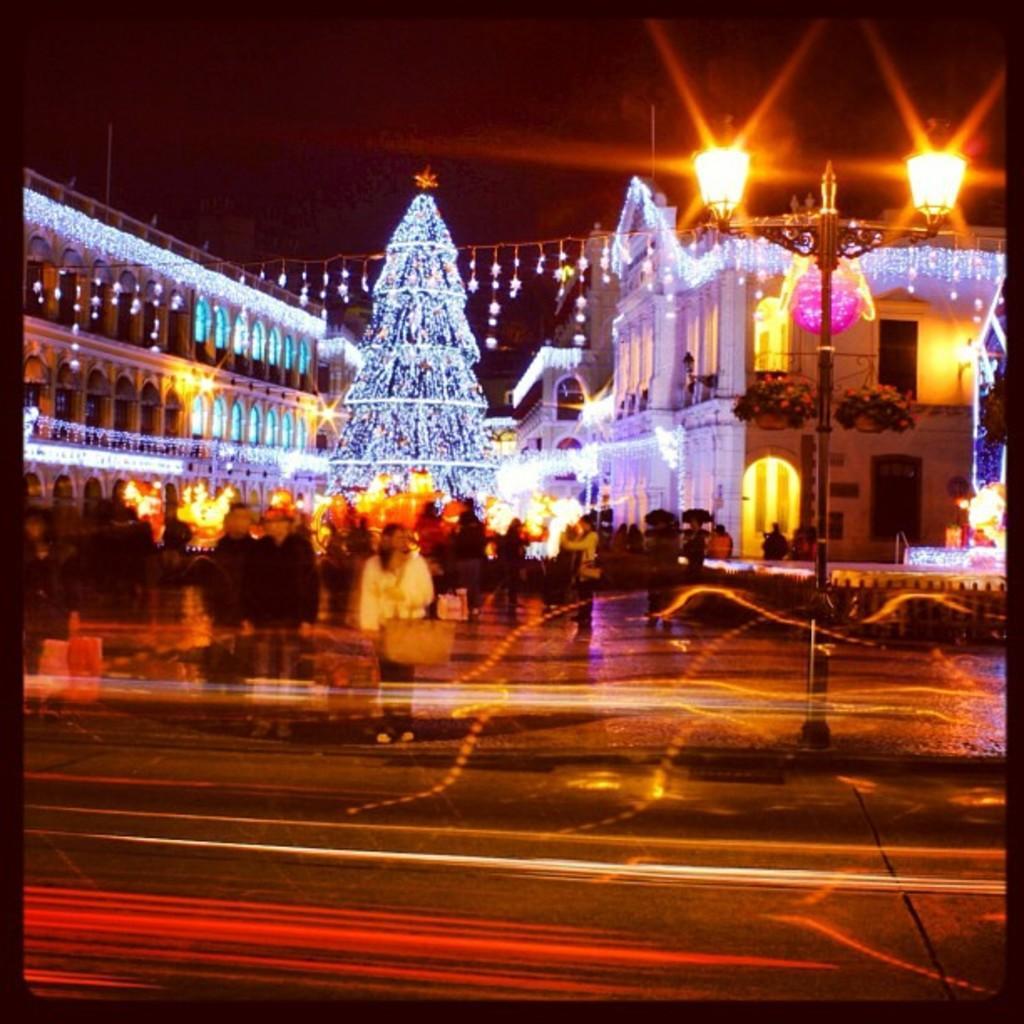Could you give a brief overview of what you see in this image? In this image there are persons standing on the road. Behind them there are buildings, lights. At the center of the image there is a Christmas tree. In the background of the image there is sky. 